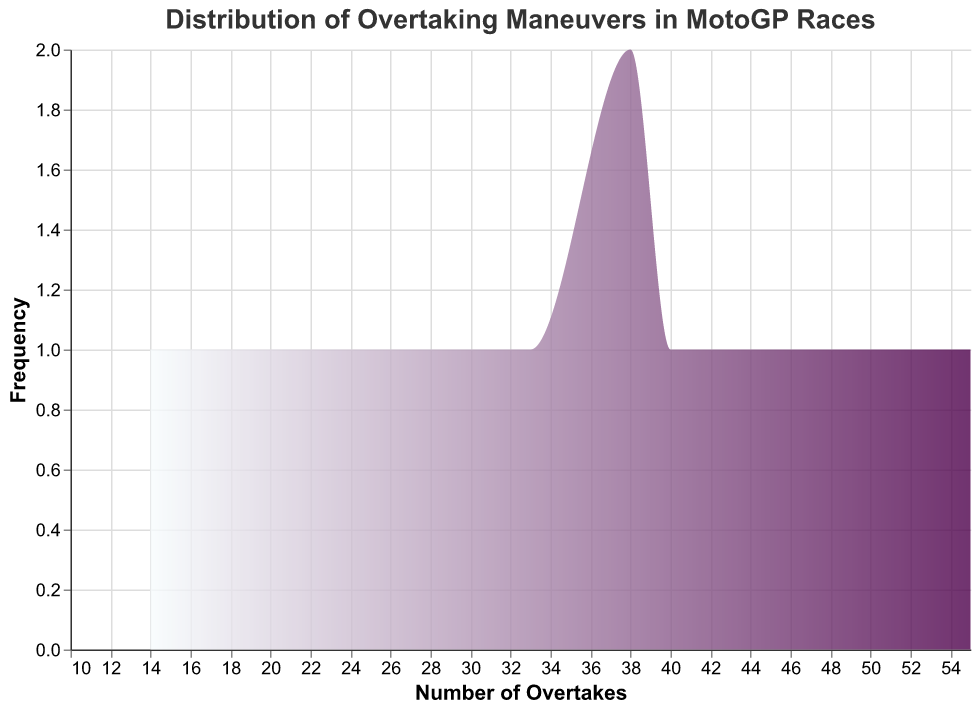What's the title of the figure? The title of the figure is displayed at the top and provides a description of the plot's subject. The figure title is "Distribution of Overtaking Maneuvers in MotoGP Races".
Answer: Distribution of Overtaking Maneuvers in MotoGP Races How many circuits are represented in the plot? Each circuit is represented by a data point on the x-axis of the density plot. Counting each unique data point gives the total number of circuits. There are 15 circuits in the plot.
Answer: 15 What circuit had the highest number of overtakes? Observing the density plot shows the highest peak on the x-axis, representing the highest number of overtakes, which is around 55. Mugello has the highest number of overtakes at 55.
Answer: Mugello What is the general trend of overtakes above and below 30 overtakes? From the density plot, it's evident that there are more circuits with overtakes below the value of 30 compared to those above 30. This implies fewer circuits see frequent high overtakes.
Answer: More circuits below 30 overtakes Which circuit had fewer overtakes, Valencia or Misano? By checking the x-axis positions corresponding to the circuits, Valencia has fewer overtakes with 18 compared to Misano with 25.
Answer: Valencia What is the average number of overtakes across all circuits? To find the average overtakes, sum all the overtakes and divide by the number of circuits: (55 + 32 + 14 + 47 + 38 + 40 + 29 + 25 + 33 + 52 + 44 + 18 + 38 + 21 + 27) / 15 = 37.4.
Answer: 37.4 How many circuits exhibit a count of overtakes between 20 and 40? From the plot, count the frequency of overtakes between 20 and 40. Circuits that fall within this range are: Silverstone, Losail, Brno, Red Bull Ring, Misano, Aragón, Circuit of the Americas, Jerez, Le Mans, totaling to 8 circuits.
Answer: 8 What can be inferred about Le Mans’ overtakes compared to Phillip Island’s? Looking at the x-axis, Le Mans has overtakes around 27 whereas Phillip Island shows 52 overtakes. Phillip Island has significantly higher overtakes.
Answer: Phillip Island has significantly higher overtakes What is the median number of overtakes across the circuits? To find the median, sort the number of overtakes and find the middle value: 14, 18, 21, 25, 27, 29, 32, 33, 38, 38, 40, 44, 47, 52, 55. The median is 33.
Answer: 33 